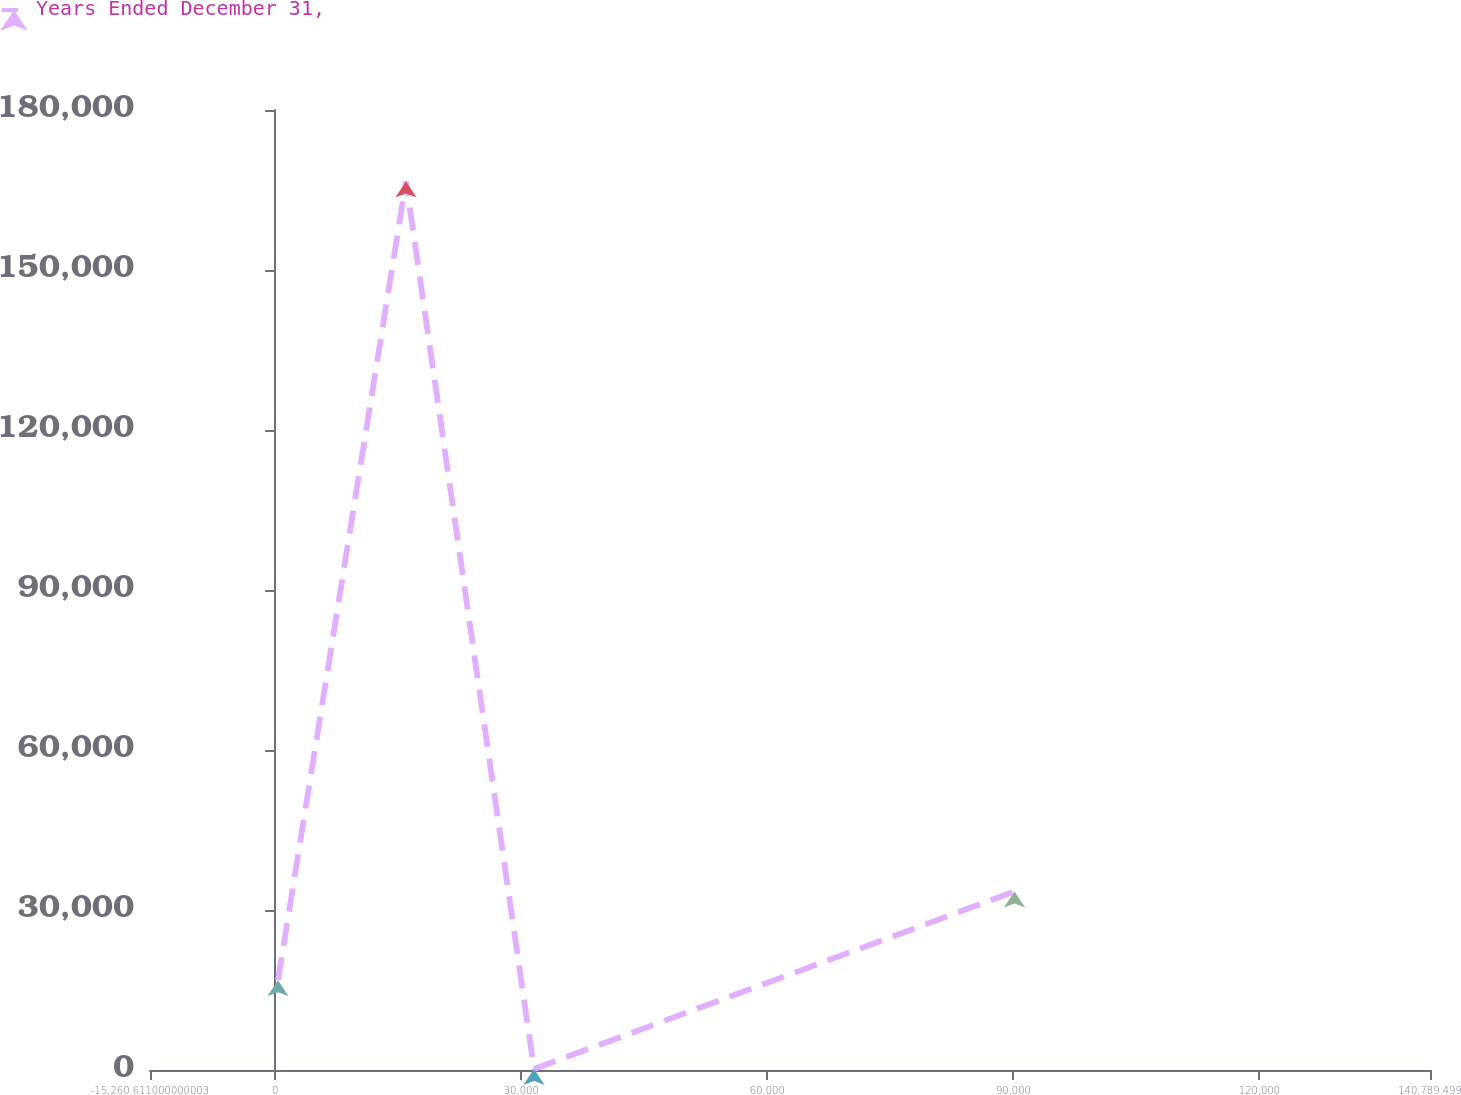Convert chart to OTSL. <chart><loc_0><loc_0><loc_500><loc_500><line_chart><ecel><fcel>Years Ended December 31,<nl><fcel>344.4<fcel>16833.3<nl><fcel>15949.4<fcel>166591<nl><fcel>31554.4<fcel>193.58<nl><fcel>90135.1<fcel>33473<nl><fcel>156395<fcel>137123<nl></chart> 